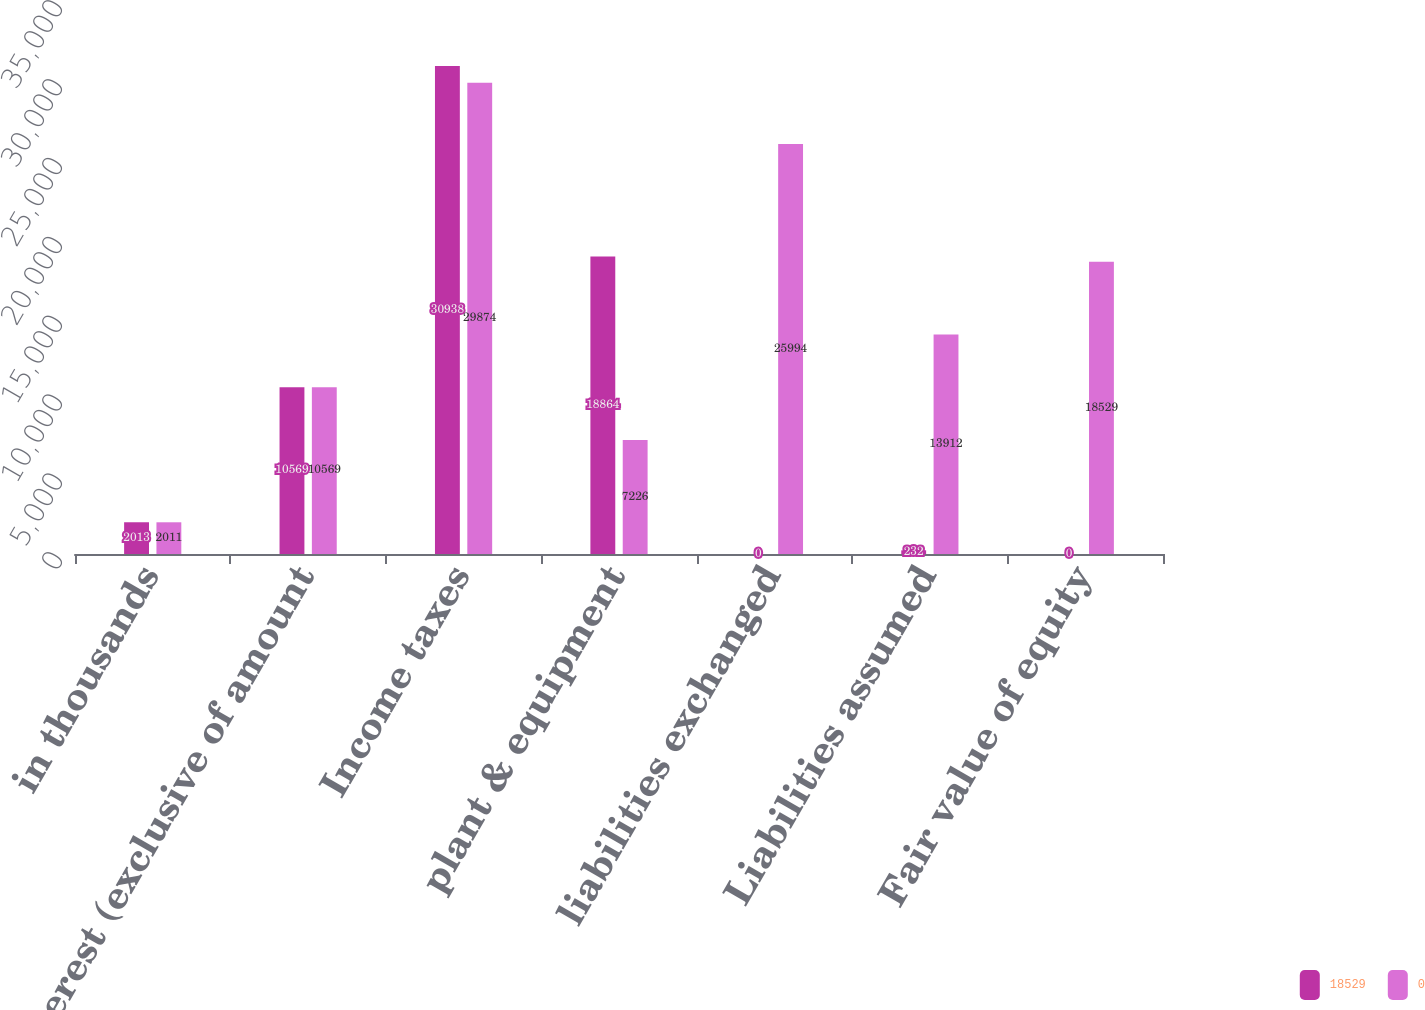Convert chart to OTSL. <chart><loc_0><loc_0><loc_500><loc_500><stacked_bar_chart><ecel><fcel>in thousands<fcel>Interest (exclusive of amount<fcel>Income taxes<fcel>plant & equipment<fcel>liabilities exchanged<fcel>Liabilities assumed<fcel>Fair value of equity<nl><fcel>18529<fcel>2013<fcel>10569<fcel>30938<fcel>18864<fcel>0<fcel>232<fcel>0<nl><fcel>0<fcel>2011<fcel>10569<fcel>29874<fcel>7226<fcel>25994<fcel>13912<fcel>18529<nl></chart> 